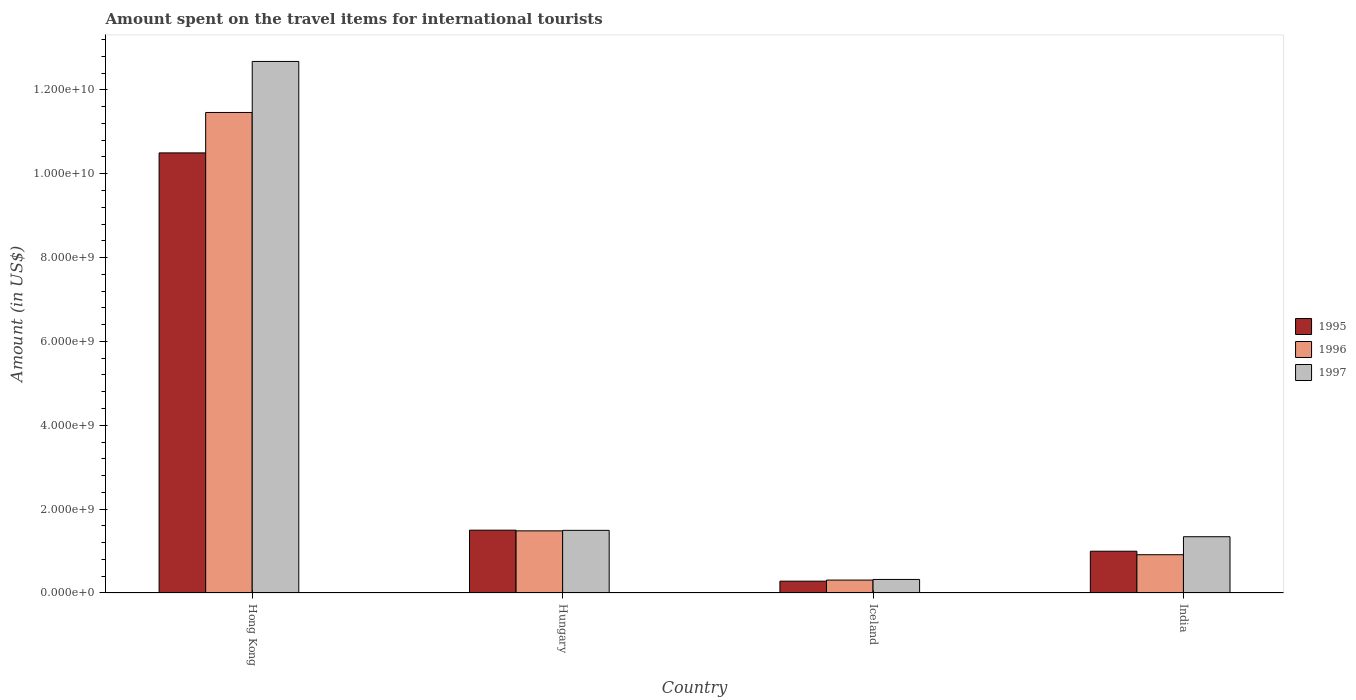How many different coloured bars are there?
Make the answer very short. 3. Are the number of bars on each tick of the X-axis equal?
Offer a very short reply. Yes. How many bars are there on the 1st tick from the right?
Your response must be concise. 3. What is the label of the 4th group of bars from the left?
Your response must be concise. India. What is the amount spent on the travel items for international tourists in 1997 in Iceland?
Your response must be concise. 3.23e+08. Across all countries, what is the maximum amount spent on the travel items for international tourists in 1995?
Make the answer very short. 1.05e+1. Across all countries, what is the minimum amount spent on the travel items for international tourists in 1995?
Keep it short and to the point. 2.82e+08. In which country was the amount spent on the travel items for international tourists in 1996 maximum?
Your answer should be compact. Hong Kong. What is the total amount spent on the travel items for international tourists in 1995 in the graph?
Provide a short and direct response. 1.33e+1. What is the difference between the amount spent on the travel items for international tourists in 1996 in Hungary and that in Iceland?
Your answer should be compact. 1.17e+09. What is the difference between the amount spent on the travel items for international tourists in 1995 in Iceland and the amount spent on the travel items for international tourists in 1997 in India?
Make the answer very short. -1.06e+09. What is the average amount spent on the travel items for international tourists in 1996 per country?
Make the answer very short. 3.54e+09. What is the difference between the amount spent on the travel items for international tourists of/in 1997 and amount spent on the travel items for international tourists of/in 1995 in Hungary?
Your answer should be very brief. -4.00e+06. In how many countries, is the amount spent on the travel items for international tourists in 1997 greater than 6800000000 US$?
Provide a short and direct response. 1. What is the ratio of the amount spent on the travel items for international tourists in 1997 in Hungary to that in India?
Your response must be concise. 1.11. Is the difference between the amount spent on the travel items for international tourists in 1997 in Hungary and India greater than the difference between the amount spent on the travel items for international tourists in 1995 in Hungary and India?
Give a very brief answer. No. What is the difference between the highest and the second highest amount spent on the travel items for international tourists in 1996?
Your response must be concise. 1.05e+1. What is the difference between the highest and the lowest amount spent on the travel items for international tourists in 1996?
Give a very brief answer. 1.12e+1. In how many countries, is the amount spent on the travel items for international tourists in 1995 greater than the average amount spent on the travel items for international tourists in 1995 taken over all countries?
Your answer should be compact. 1. What does the 3rd bar from the left in Iceland represents?
Keep it short and to the point. 1997. How many bars are there?
Provide a short and direct response. 12. Are all the bars in the graph horizontal?
Provide a short and direct response. No. What is the difference between two consecutive major ticks on the Y-axis?
Ensure brevity in your answer.  2.00e+09. Does the graph contain grids?
Keep it short and to the point. No. Where does the legend appear in the graph?
Provide a short and direct response. Center right. What is the title of the graph?
Give a very brief answer. Amount spent on the travel items for international tourists. What is the label or title of the Y-axis?
Your answer should be compact. Amount (in US$). What is the Amount (in US$) in 1995 in Hong Kong?
Offer a terse response. 1.05e+1. What is the Amount (in US$) of 1996 in Hong Kong?
Your response must be concise. 1.15e+1. What is the Amount (in US$) in 1997 in Hong Kong?
Provide a short and direct response. 1.27e+1. What is the Amount (in US$) in 1995 in Hungary?
Offer a very short reply. 1.50e+09. What is the Amount (in US$) in 1996 in Hungary?
Provide a short and direct response. 1.48e+09. What is the Amount (in US$) in 1997 in Hungary?
Keep it short and to the point. 1.49e+09. What is the Amount (in US$) of 1995 in Iceland?
Your answer should be compact. 2.82e+08. What is the Amount (in US$) in 1996 in Iceland?
Your response must be concise. 3.08e+08. What is the Amount (in US$) in 1997 in Iceland?
Make the answer very short. 3.23e+08. What is the Amount (in US$) of 1995 in India?
Offer a very short reply. 9.96e+08. What is the Amount (in US$) in 1996 in India?
Offer a very short reply. 9.13e+08. What is the Amount (in US$) of 1997 in India?
Make the answer very short. 1.34e+09. Across all countries, what is the maximum Amount (in US$) of 1995?
Your answer should be compact. 1.05e+1. Across all countries, what is the maximum Amount (in US$) of 1996?
Give a very brief answer. 1.15e+1. Across all countries, what is the maximum Amount (in US$) in 1997?
Give a very brief answer. 1.27e+1. Across all countries, what is the minimum Amount (in US$) in 1995?
Keep it short and to the point. 2.82e+08. Across all countries, what is the minimum Amount (in US$) of 1996?
Provide a succinct answer. 3.08e+08. Across all countries, what is the minimum Amount (in US$) in 1997?
Your response must be concise. 3.23e+08. What is the total Amount (in US$) in 1995 in the graph?
Provide a succinct answer. 1.33e+1. What is the total Amount (in US$) of 1996 in the graph?
Your response must be concise. 1.42e+1. What is the total Amount (in US$) in 1997 in the graph?
Provide a short and direct response. 1.58e+1. What is the difference between the Amount (in US$) of 1995 in Hong Kong and that in Hungary?
Keep it short and to the point. 9.00e+09. What is the difference between the Amount (in US$) of 1996 in Hong Kong and that in Hungary?
Offer a very short reply. 9.98e+09. What is the difference between the Amount (in US$) in 1997 in Hong Kong and that in Hungary?
Ensure brevity in your answer.  1.12e+1. What is the difference between the Amount (in US$) of 1995 in Hong Kong and that in Iceland?
Keep it short and to the point. 1.02e+1. What is the difference between the Amount (in US$) in 1996 in Hong Kong and that in Iceland?
Your response must be concise. 1.12e+1. What is the difference between the Amount (in US$) in 1997 in Hong Kong and that in Iceland?
Your answer should be very brief. 1.24e+1. What is the difference between the Amount (in US$) in 1995 in Hong Kong and that in India?
Your response must be concise. 9.50e+09. What is the difference between the Amount (in US$) in 1996 in Hong Kong and that in India?
Your answer should be compact. 1.05e+1. What is the difference between the Amount (in US$) in 1997 in Hong Kong and that in India?
Offer a terse response. 1.13e+1. What is the difference between the Amount (in US$) of 1995 in Hungary and that in Iceland?
Offer a terse response. 1.22e+09. What is the difference between the Amount (in US$) in 1996 in Hungary and that in Iceland?
Provide a succinct answer. 1.17e+09. What is the difference between the Amount (in US$) of 1997 in Hungary and that in Iceland?
Give a very brief answer. 1.17e+09. What is the difference between the Amount (in US$) of 1995 in Hungary and that in India?
Your response must be concise. 5.02e+08. What is the difference between the Amount (in US$) in 1996 in Hungary and that in India?
Give a very brief answer. 5.69e+08. What is the difference between the Amount (in US$) in 1997 in Hungary and that in India?
Keep it short and to the point. 1.52e+08. What is the difference between the Amount (in US$) of 1995 in Iceland and that in India?
Give a very brief answer. -7.14e+08. What is the difference between the Amount (in US$) of 1996 in Iceland and that in India?
Offer a terse response. -6.05e+08. What is the difference between the Amount (in US$) of 1997 in Iceland and that in India?
Offer a terse response. -1.02e+09. What is the difference between the Amount (in US$) of 1995 in Hong Kong and the Amount (in US$) of 1996 in Hungary?
Provide a succinct answer. 9.02e+09. What is the difference between the Amount (in US$) in 1995 in Hong Kong and the Amount (in US$) in 1997 in Hungary?
Make the answer very short. 9.00e+09. What is the difference between the Amount (in US$) of 1996 in Hong Kong and the Amount (in US$) of 1997 in Hungary?
Keep it short and to the point. 9.97e+09. What is the difference between the Amount (in US$) in 1995 in Hong Kong and the Amount (in US$) in 1996 in Iceland?
Offer a very short reply. 1.02e+1. What is the difference between the Amount (in US$) in 1995 in Hong Kong and the Amount (in US$) in 1997 in Iceland?
Give a very brief answer. 1.02e+1. What is the difference between the Amount (in US$) of 1996 in Hong Kong and the Amount (in US$) of 1997 in Iceland?
Provide a short and direct response. 1.11e+1. What is the difference between the Amount (in US$) of 1995 in Hong Kong and the Amount (in US$) of 1996 in India?
Offer a terse response. 9.58e+09. What is the difference between the Amount (in US$) in 1995 in Hong Kong and the Amount (in US$) in 1997 in India?
Provide a succinct answer. 9.16e+09. What is the difference between the Amount (in US$) in 1996 in Hong Kong and the Amount (in US$) in 1997 in India?
Ensure brevity in your answer.  1.01e+1. What is the difference between the Amount (in US$) of 1995 in Hungary and the Amount (in US$) of 1996 in Iceland?
Keep it short and to the point. 1.19e+09. What is the difference between the Amount (in US$) in 1995 in Hungary and the Amount (in US$) in 1997 in Iceland?
Keep it short and to the point. 1.18e+09. What is the difference between the Amount (in US$) in 1996 in Hungary and the Amount (in US$) in 1997 in Iceland?
Your answer should be compact. 1.16e+09. What is the difference between the Amount (in US$) of 1995 in Hungary and the Amount (in US$) of 1996 in India?
Offer a very short reply. 5.85e+08. What is the difference between the Amount (in US$) in 1995 in Hungary and the Amount (in US$) in 1997 in India?
Offer a very short reply. 1.56e+08. What is the difference between the Amount (in US$) of 1996 in Hungary and the Amount (in US$) of 1997 in India?
Your answer should be compact. 1.40e+08. What is the difference between the Amount (in US$) in 1995 in Iceland and the Amount (in US$) in 1996 in India?
Offer a very short reply. -6.31e+08. What is the difference between the Amount (in US$) in 1995 in Iceland and the Amount (in US$) in 1997 in India?
Provide a succinct answer. -1.06e+09. What is the difference between the Amount (in US$) of 1996 in Iceland and the Amount (in US$) of 1997 in India?
Provide a short and direct response. -1.03e+09. What is the average Amount (in US$) of 1995 per country?
Your answer should be very brief. 3.32e+09. What is the average Amount (in US$) in 1996 per country?
Your answer should be compact. 3.54e+09. What is the average Amount (in US$) in 1997 per country?
Keep it short and to the point. 3.96e+09. What is the difference between the Amount (in US$) in 1995 and Amount (in US$) in 1996 in Hong Kong?
Provide a short and direct response. -9.64e+08. What is the difference between the Amount (in US$) in 1995 and Amount (in US$) in 1997 in Hong Kong?
Ensure brevity in your answer.  -2.18e+09. What is the difference between the Amount (in US$) in 1996 and Amount (in US$) in 1997 in Hong Kong?
Make the answer very short. -1.22e+09. What is the difference between the Amount (in US$) of 1995 and Amount (in US$) of 1996 in Hungary?
Offer a very short reply. 1.60e+07. What is the difference between the Amount (in US$) of 1996 and Amount (in US$) of 1997 in Hungary?
Provide a succinct answer. -1.20e+07. What is the difference between the Amount (in US$) in 1995 and Amount (in US$) in 1996 in Iceland?
Provide a succinct answer. -2.60e+07. What is the difference between the Amount (in US$) of 1995 and Amount (in US$) of 1997 in Iceland?
Keep it short and to the point. -4.10e+07. What is the difference between the Amount (in US$) of 1996 and Amount (in US$) of 1997 in Iceland?
Offer a terse response. -1.50e+07. What is the difference between the Amount (in US$) in 1995 and Amount (in US$) in 1996 in India?
Make the answer very short. 8.30e+07. What is the difference between the Amount (in US$) of 1995 and Amount (in US$) of 1997 in India?
Give a very brief answer. -3.46e+08. What is the difference between the Amount (in US$) of 1996 and Amount (in US$) of 1997 in India?
Give a very brief answer. -4.29e+08. What is the ratio of the Amount (in US$) of 1995 in Hong Kong to that in Hungary?
Keep it short and to the point. 7.01. What is the ratio of the Amount (in US$) in 1996 in Hong Kong to that in Hungary?
Keep it short and to the point. 7.73. What is the ratio of the Amount (in US$) in 1997 in Hong Kong to that in Hungary?
Offer a terse response. 8.49. What is the ratio of the Amount (in US$) of 1995 in Hong Kong to that in Iceland?
Provide a short and direct response. 37.22. What is the ratio of the Amount (in US$) of 1996 in Hong Kong to that in Iceland?
Your answer should be compact. 37.21. What is the ratio of the Amount (in US$) of 1997 in Hong Kong to that in Iceland?
Keep it short and to the point. 39.25. What is the ratio of the Amount (in US$) in 1995 in Hong Kong to that in India?
Your answer should be very brief. 10.54. What is the ratio of the Amount (in US$) in 1996 in Hong Kong to that in India?
Offer a very short reply. 12.55. What is the ratio of the Amount (in US$) in 1997 in Hong Kong to that in India?
Your response must be concise. 9.45. What is the ratio of the Amount (in US$) of 1995 in Hungary to that in Iceland?
Provide a short and direct response. 5.31. What is the ratio of the Amount (in US$) in 1996 in Hungary to that in Iceland?
Keep it short and to the point. 4.81. What is the ratio of the Amount (in US$) in 1997 in Hungary to that in Iceland?
Provide a succinct answer. 4.63. What is the ratio of the Amount (in US$) in 1995 in Hungary to that in India?
Keep it short and to the point. 1.5. What is the ratio of the Amount (in US$) in 1996 in Hungary to that in India?
Offer a terse response. 1.62. What is the ratio of the Amount (in US$) in 1997 in Hungary to that in India?
Your response must be concise. 1.11. What is the ratio of the Amount (in US$) of 1995 in Iceland to that in India?
Offer a terse response. 0.28. What is the ratio of the Amount (in US$) of 1996 in Iceland to that in India?
Offer a terse response. 0.34. What is the ratio of the Amount (in US$) of 1997 in Iceland to that in India?
Your answer should be very brief. 0.24. What is the difference between the highest and the second highest Amount (in US$) in 1995?
Ensure brevity in your answer.  9.00e+09. What is the difference between the highest and the second highest Amount (in US$) in 1996?
Your response must be concise. 9.98e+09. What is the difference between the highest and the second highest Amount (in US$) of 1997?
Your response must be concise. 1.12e+1. What is the difference between the highest and the lowest Amount (in US$) of 1995?
Make the answer very short. 1.02e+1. What is the difference between the highest and the lowest Amount (in US$) of 1996?
Offer a very short reply. 1.12e+1. What is the difference between the highest and the lowest Amount (in US$) in 1997?
Make the answer very short. 1.24e+1. 